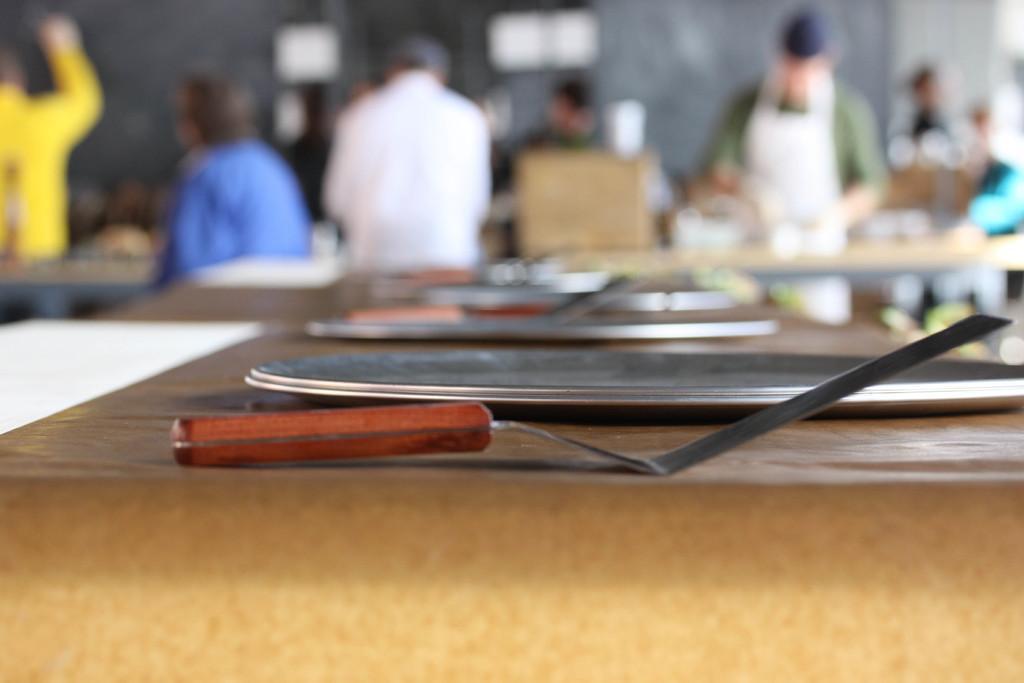Can you describe this image briefly? In this photo there are some spoons and plates kept on the table. In the backdrop their people some of them are standing and some of them are sitting 